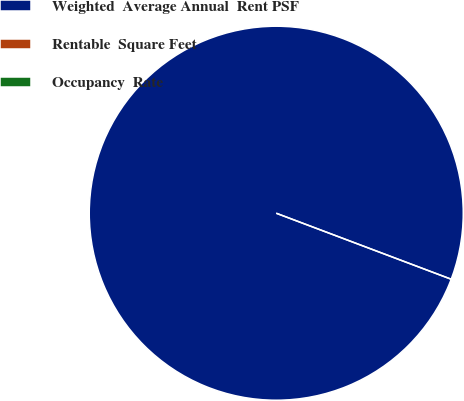<chart> <loc_0><loc_0><loc_500><loc_500><pie_chart><fcel>Weighted  Average Annual  Rent PSF<fcel>Rentable  Square Feet<fcel>Occupancy  Rate<nl><fcel>100.0%<fcel>0.0%<fcel>0.0%<nl></chart> 